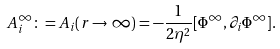Convert formula to latex. <formula><loc_0><loc_0><loc_500><loc_500>A _ { i } ^ { \infty } \colon = A _ { i } ( r \rightarrow \infty ) = - \frac { 1 } { 2 \eta ^ { 2 } } [ \Phi ^ { \infty } , \partial _ { i } \Phi ^ { \infty } ] .</formula> 